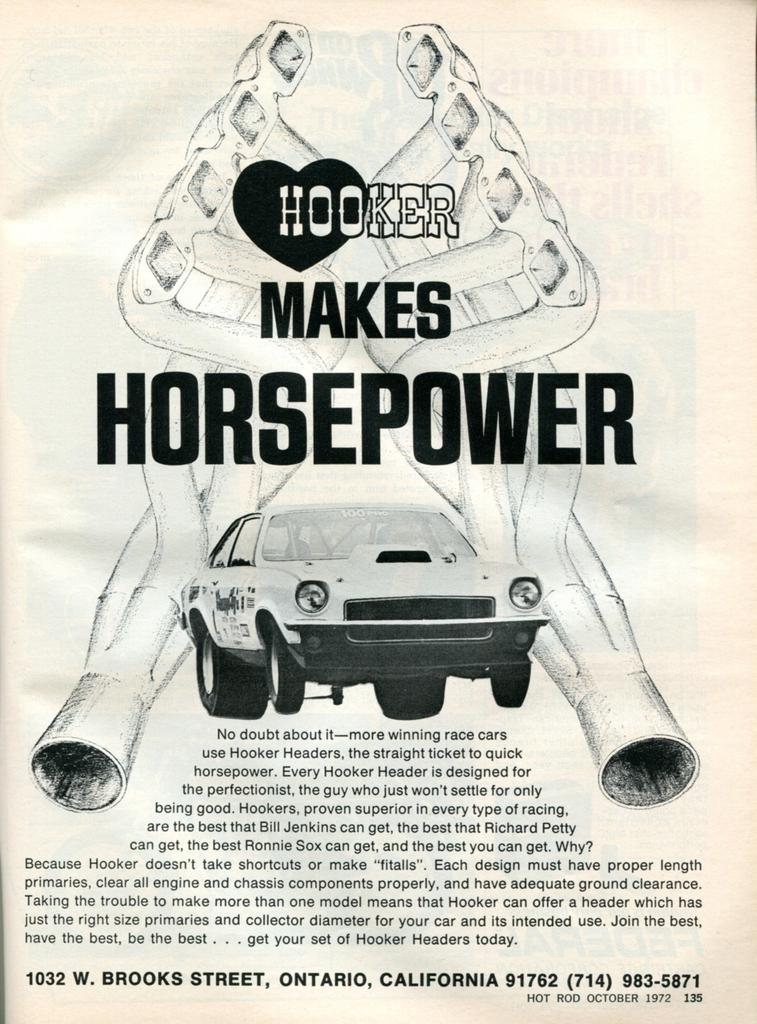What type of image is featured on the poster? The poster contains an animated image. What color are the texts on the poster? The texts on the poster are black. What is the main object in the image? There is a vehicle in the image. How many designs can be seen in the image? There are two designs in the image. What color is the background of the image? The background of the image is white. What type of plantation is shown in the image? There is no plantation present in the image; it features an animated image with a vehicle and two designs. How many words are written on the poster? The question cannot be answered definitively as the number of words is not mentioned in the provided facts. 